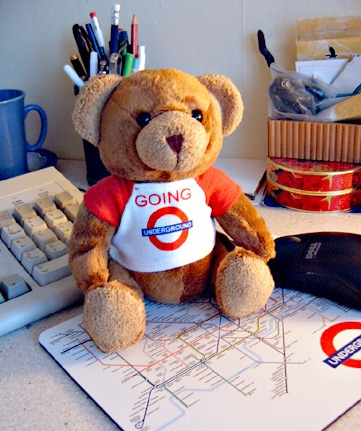Describe the objects in this image and their specific colors. I can see teddy bear in gray, maroon, tan, and white tones, keyboard in gray, darkgray, and tan tones, mouse in gray, black, navy, and maroon tones, cup in gray, blue, and navy tones, and cup in gray, black, maroon, brown, and purple tones in this image. 